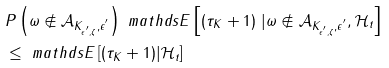<formula> <loc_0><loc_0><loc_500><loc_500>& P \left ( \omega \notin \mathcal { A } _ { K _ { \epsilon ^ { ^ { \prime } } , \zeta } , \epsilon ^ { ^ { \prime } } } \right ) \ m a t h d s { E } \left [ ( \tau _ { K } + 1 ) \ | \omega \notin \mathcal { A } _ { K _ { \epsilon ^ { ^ { \prime } } , \zeta } , \epsilon ^ { ^ { \prime } } } , \mathcal { H } _ { t } \right ] \\ & \leq \ m a t h d s { E } \left [ ( \tau _ { K } + 1 ) | \mathcal { H } _ { t } \right ]</formula> 